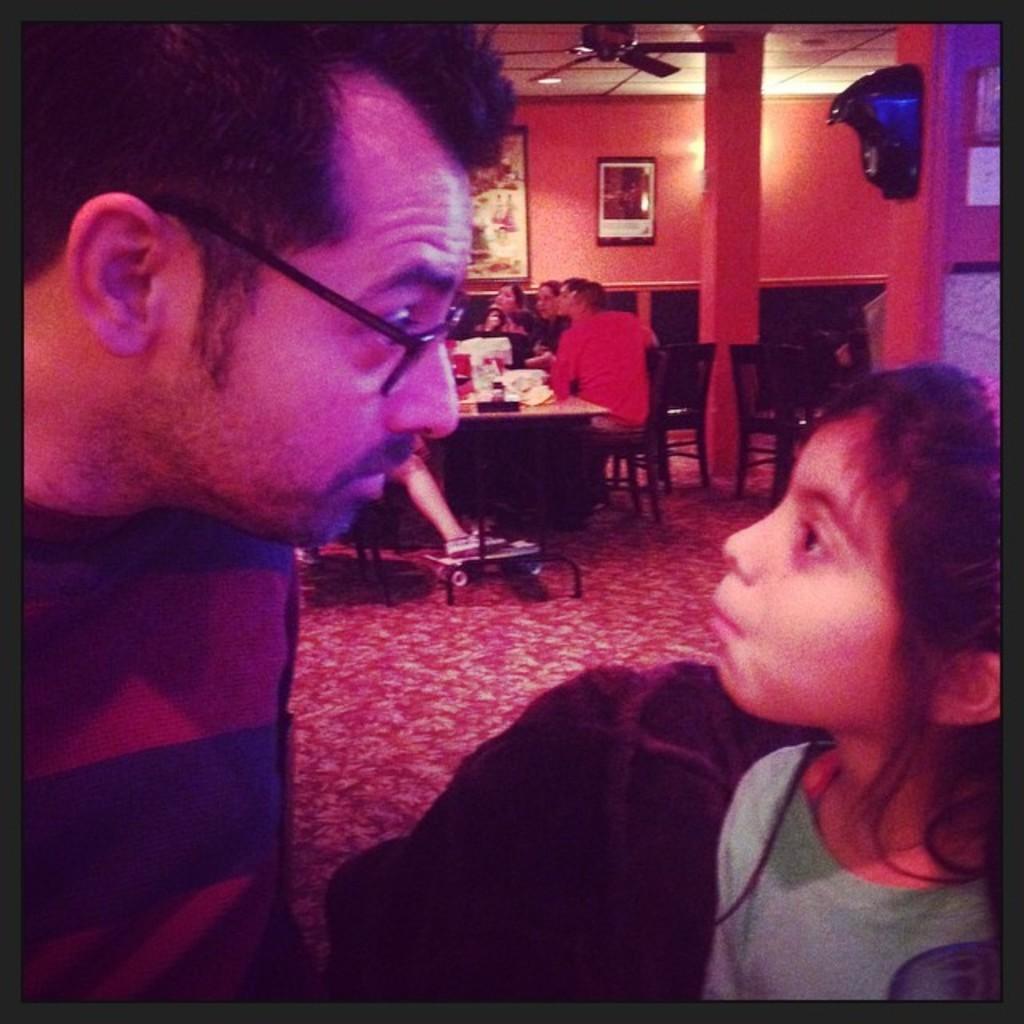Could you give a brief overview of what you see in this image? This picture shows people seated on the chairs and we see a table and couple photo frames on the wall and we see a man and a girl seated on the chairs and we see a ceiling fan. 